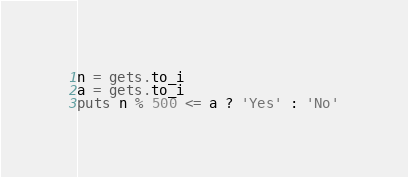Convert code to text. <code><loc_0><loc_0><loc_500><loc_500><_Ruby_>n = gets.to_i
a = gets.to_i
puts n % 500 <= a ? 'Yes' : 'No'</code> 